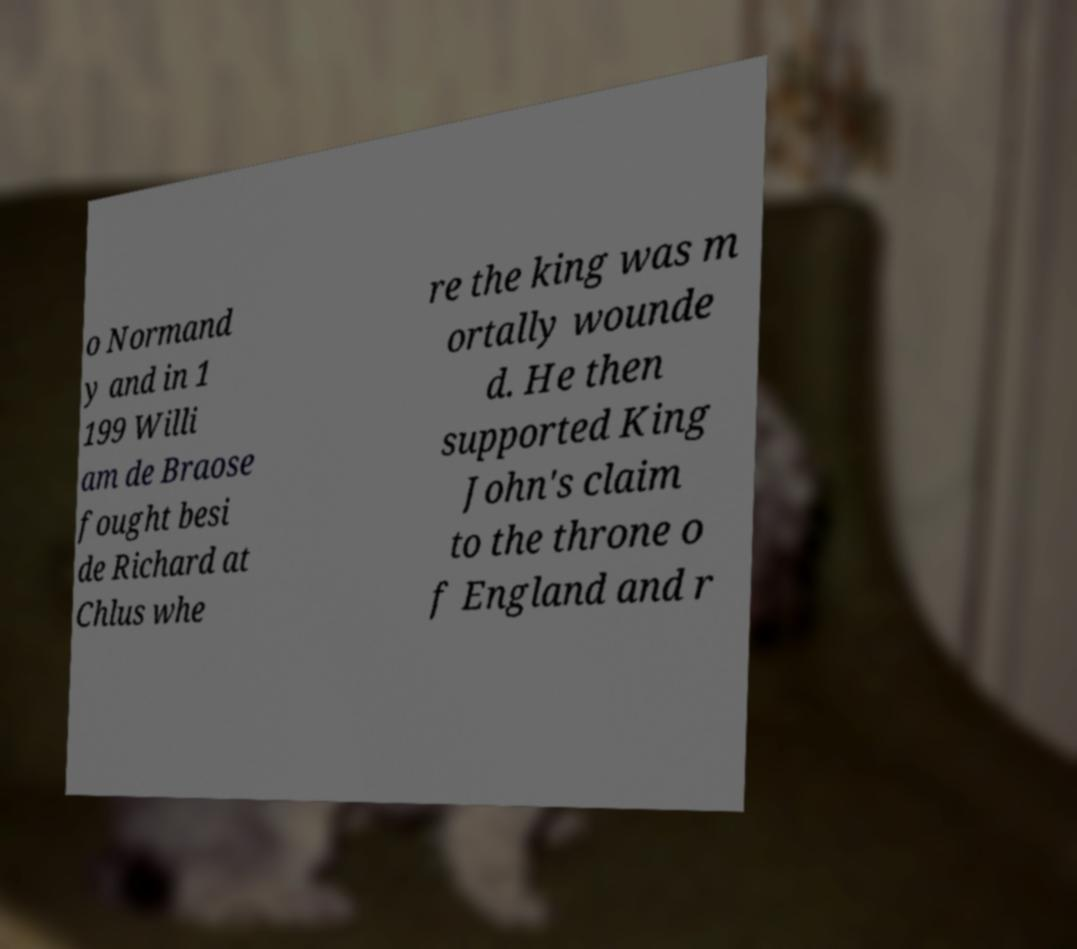Can you read and provide the text displayed in the image?This photo seems to have some interesting text. Can you extract and type it out for me? o Normand y and in 1 199 Willi am de Braose fought besi de Richard at Chlus whe re the king was m ortally wounde d. He then supported King John's claim to the throne o f England and r 